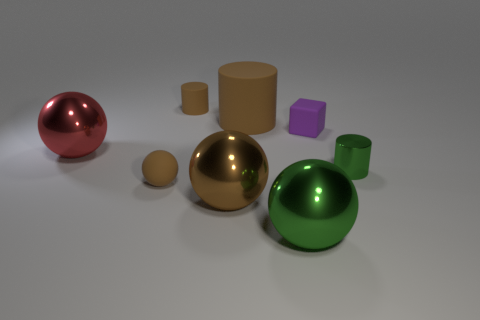What shapes and colors are present in the image? The image showcases a variety of geometric shapes including spheres, cylinders, cubes, and a hemisphere. The colors in the image include a vibrant red for the hemisphere, a shiny green for the large sphere, a golden hue for the other sphere, and varying shades of beige and purple for the cubes and cylindrical objects. The combination of shapes and colors creates a visually interesting assortment, highlighting the contrast between curved and angular forms. What might be the purpose of arranging these objects together? The arrangement of objects could serve several purposes. It may be an artistic display meant to demonstrate the interplay of light and shadow on different surfaces and shapes. Alternatively, it could be a setup for a 3D modeling or rendering exercise, aimed at practicing material creation, or for a photography composition study, emphasizing form and color. The assortment allows observers to compare characteristics such as reflectivity and shape directly. 